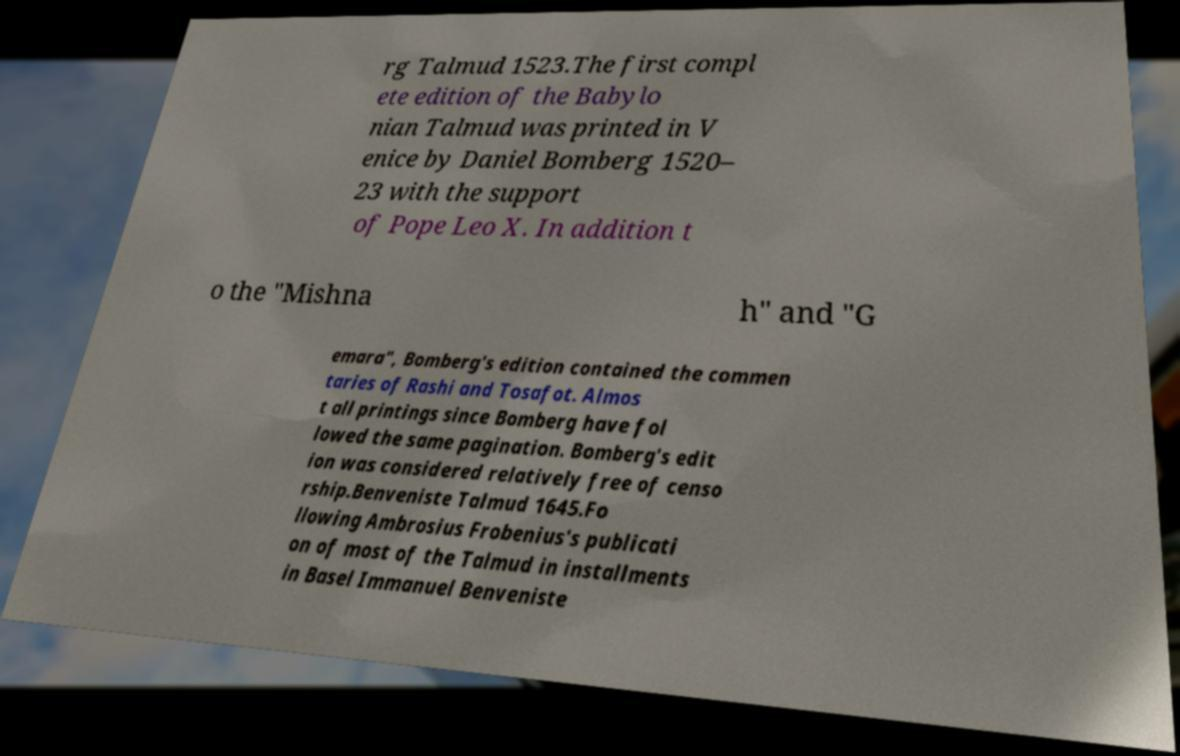What messages or text are displayed in this image? I need them in a readable, typed format. rg Talmud 1523.The first compl ete edition of the Babylo nian Talmud was printed in V enice by Daniel Bomberg 1520– 23 with the support of Pope Leo X. In addition t o the "Mishna h" and "G emara", Bomberg's edition contained the commen taries of Rashi and Tosafot. Almos t all printings since Bomberg have fol lowed the same pagination. Bomberg's edit ion was considered relatively free of censo rship.Benveniste Talmud 1645.Fo llowing Ambrosius Frobenius's publicati on of most of the Talmud in installments in Basel Immanuel Benveniste 